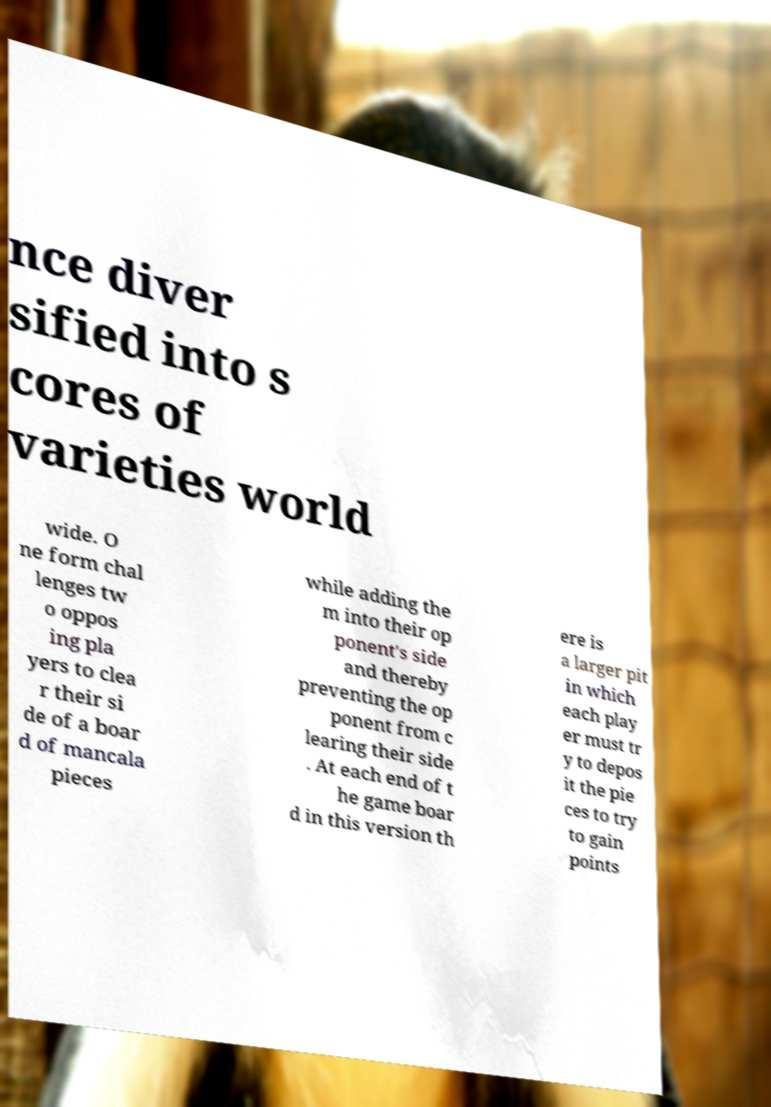There's text embedded in this image that I need extracted. Can you transcribe it verbatim? nce diver sified into s cores of varieties world wide. O ne form chal lenges tw o oppos ing pla yers to clea r their si de of a boar d of mancala pieces while adding the m into their op ponent's side and thereby preventing the op ponent from c learing their side . At each end of t he game boar d in this version th ere is a larger pit in which each play er must tr y to depos it the pie ces to try to gain points 